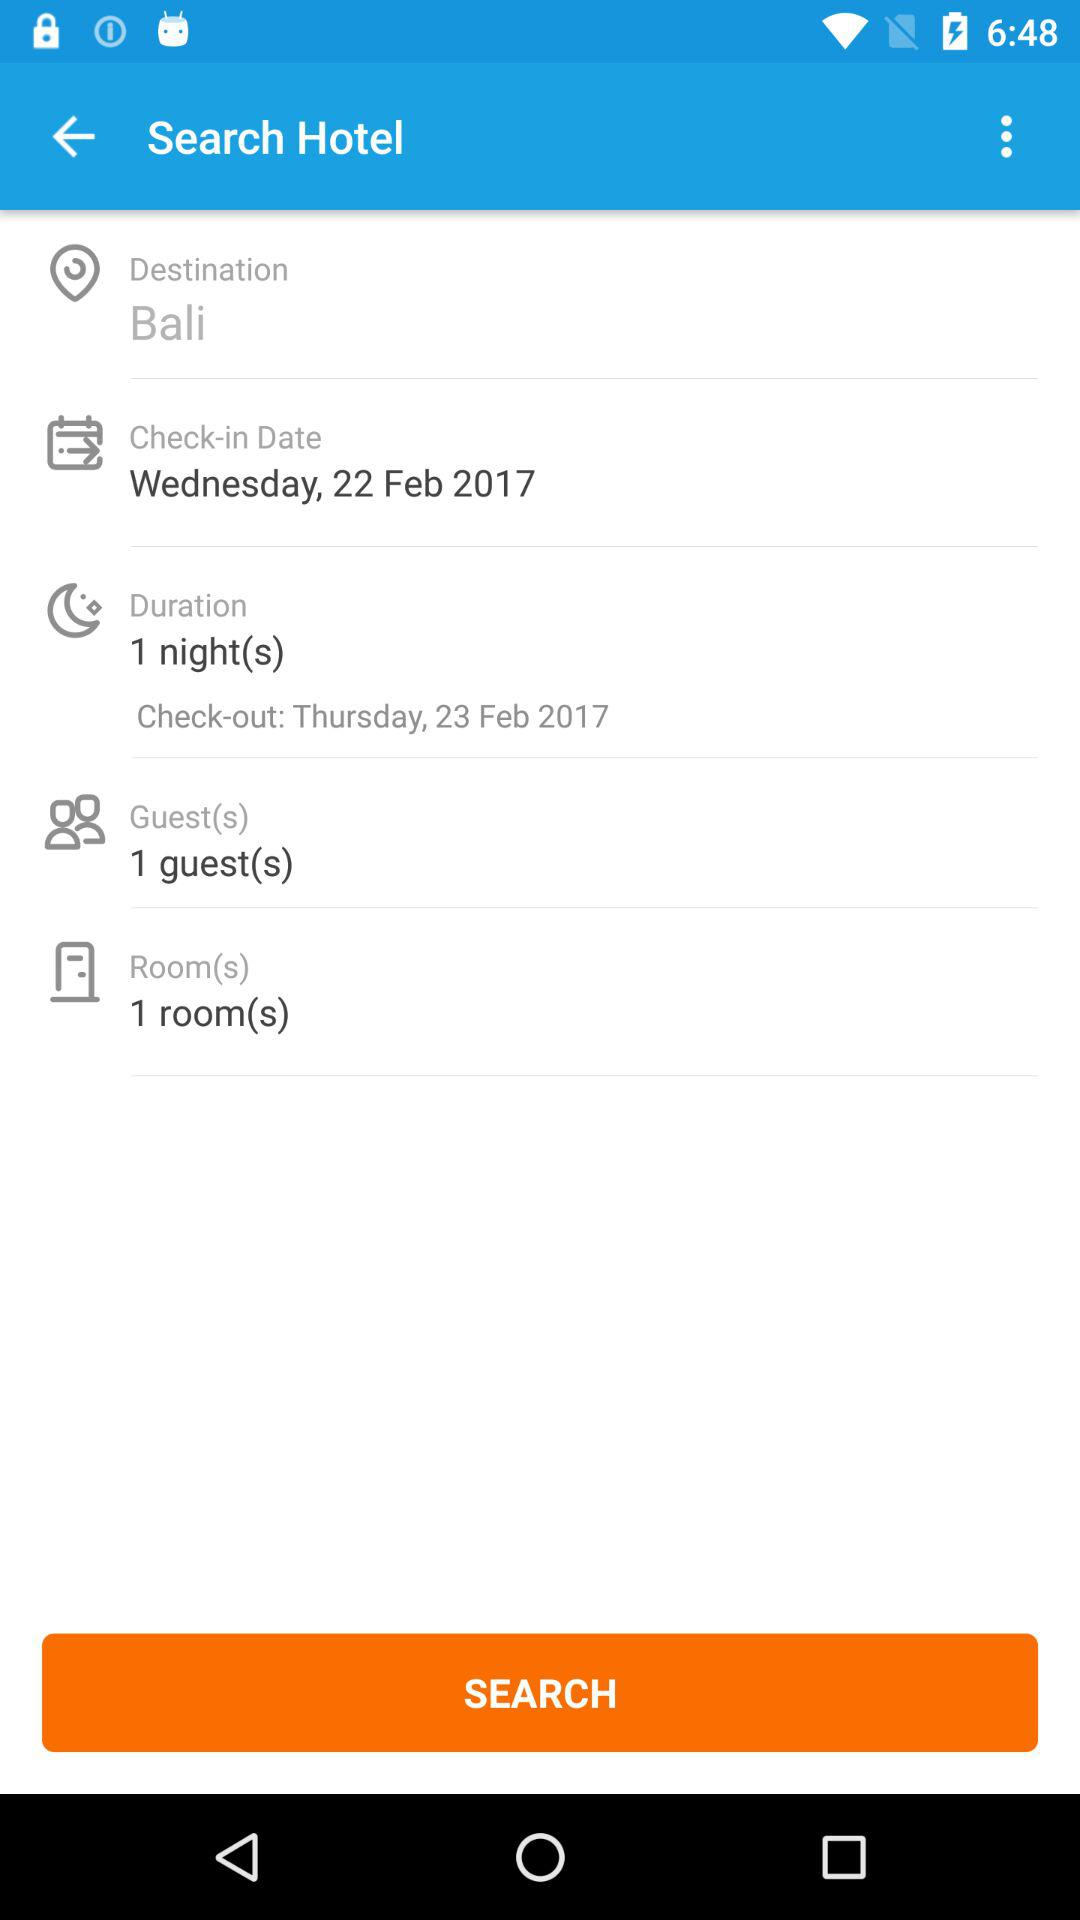What is the duration of the stay in the hotel? The duration is one night. 